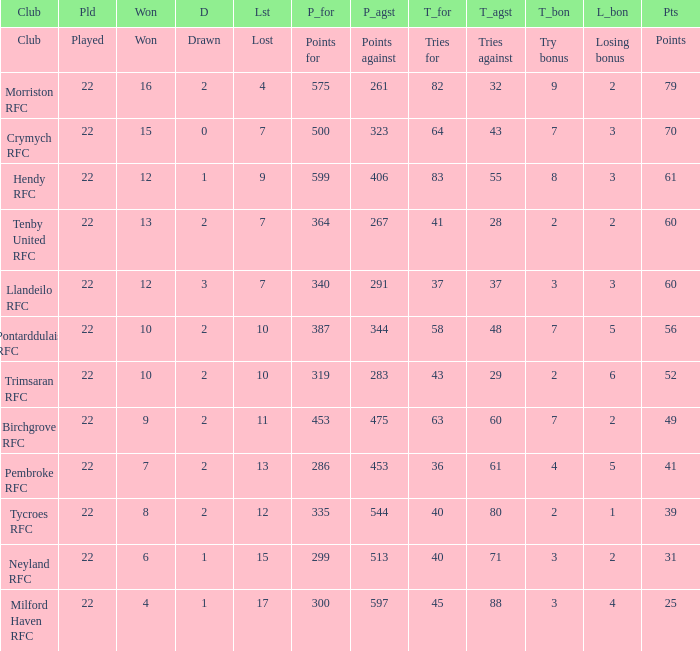What's the won with points against being 597 4.0. 